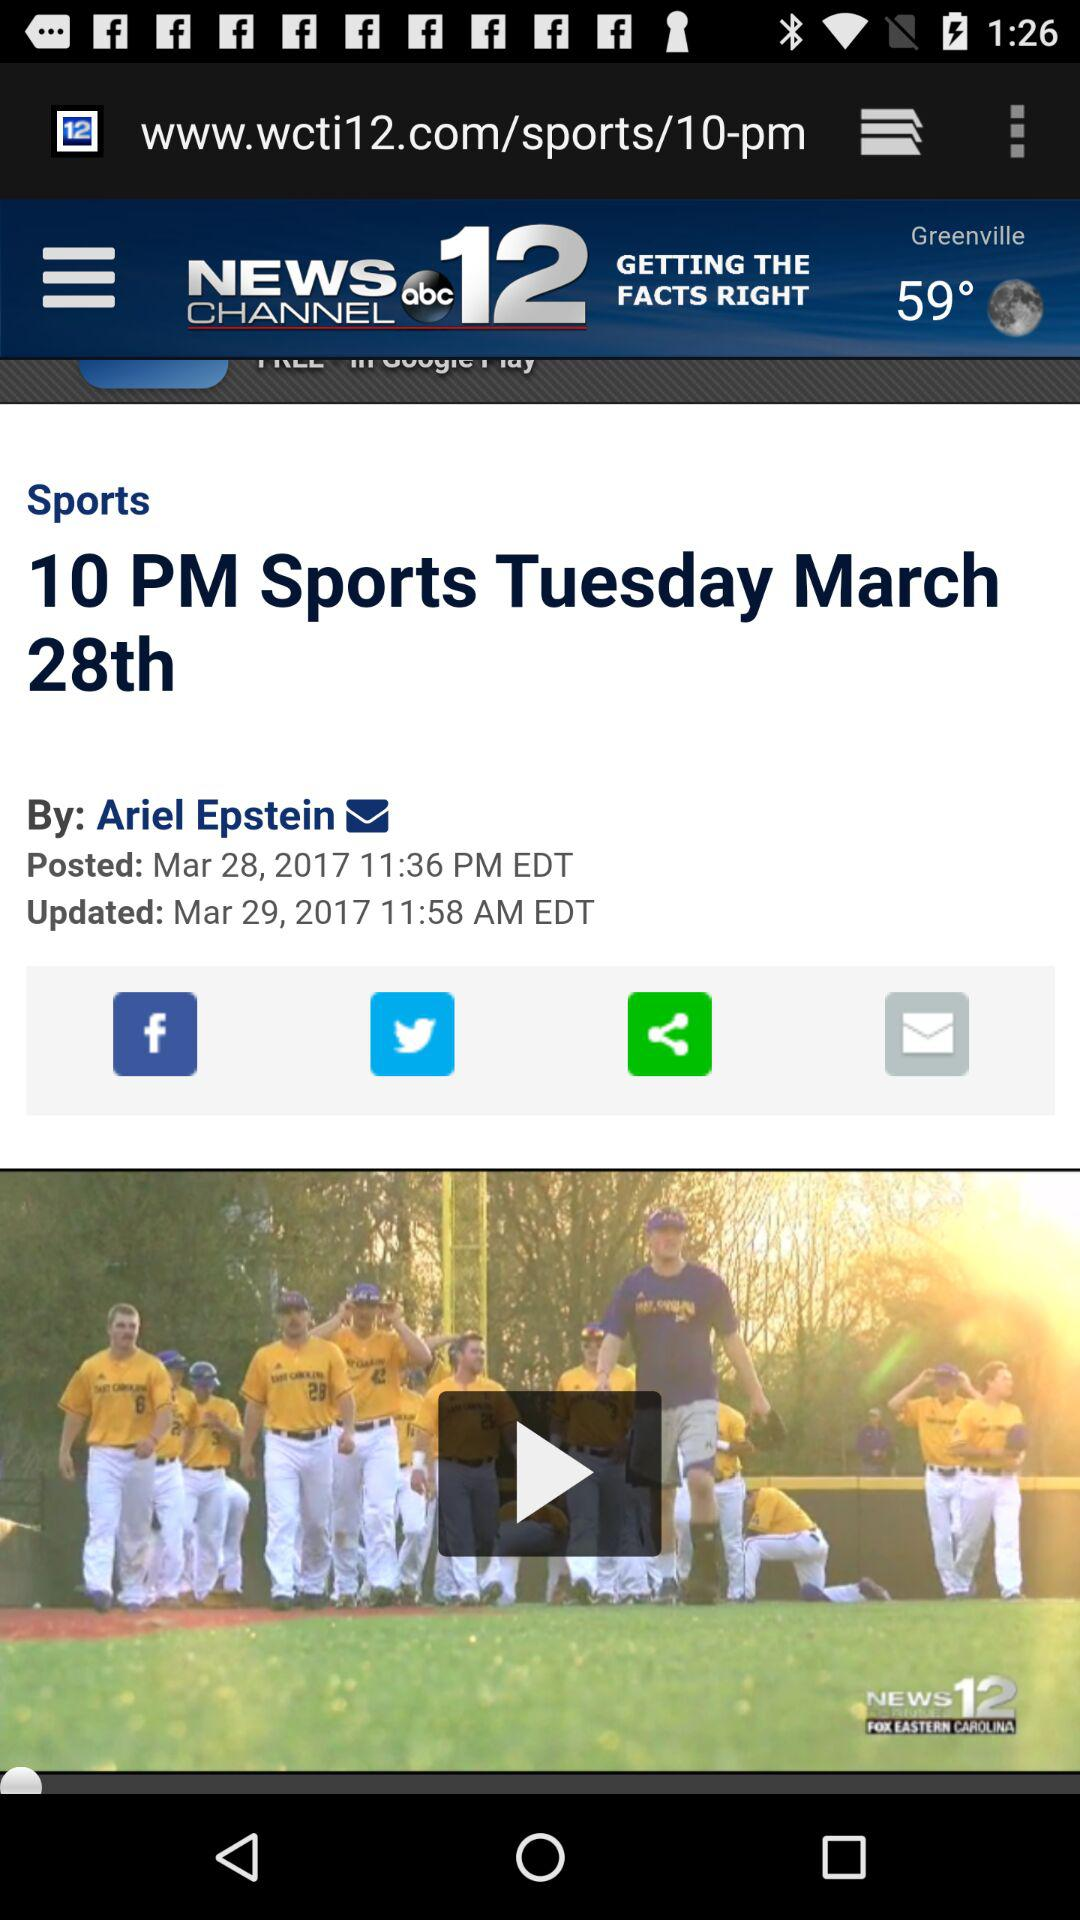When was the sports news updated? The sports news was updated on March 29, 2017 at 11:58 AM EDT. 